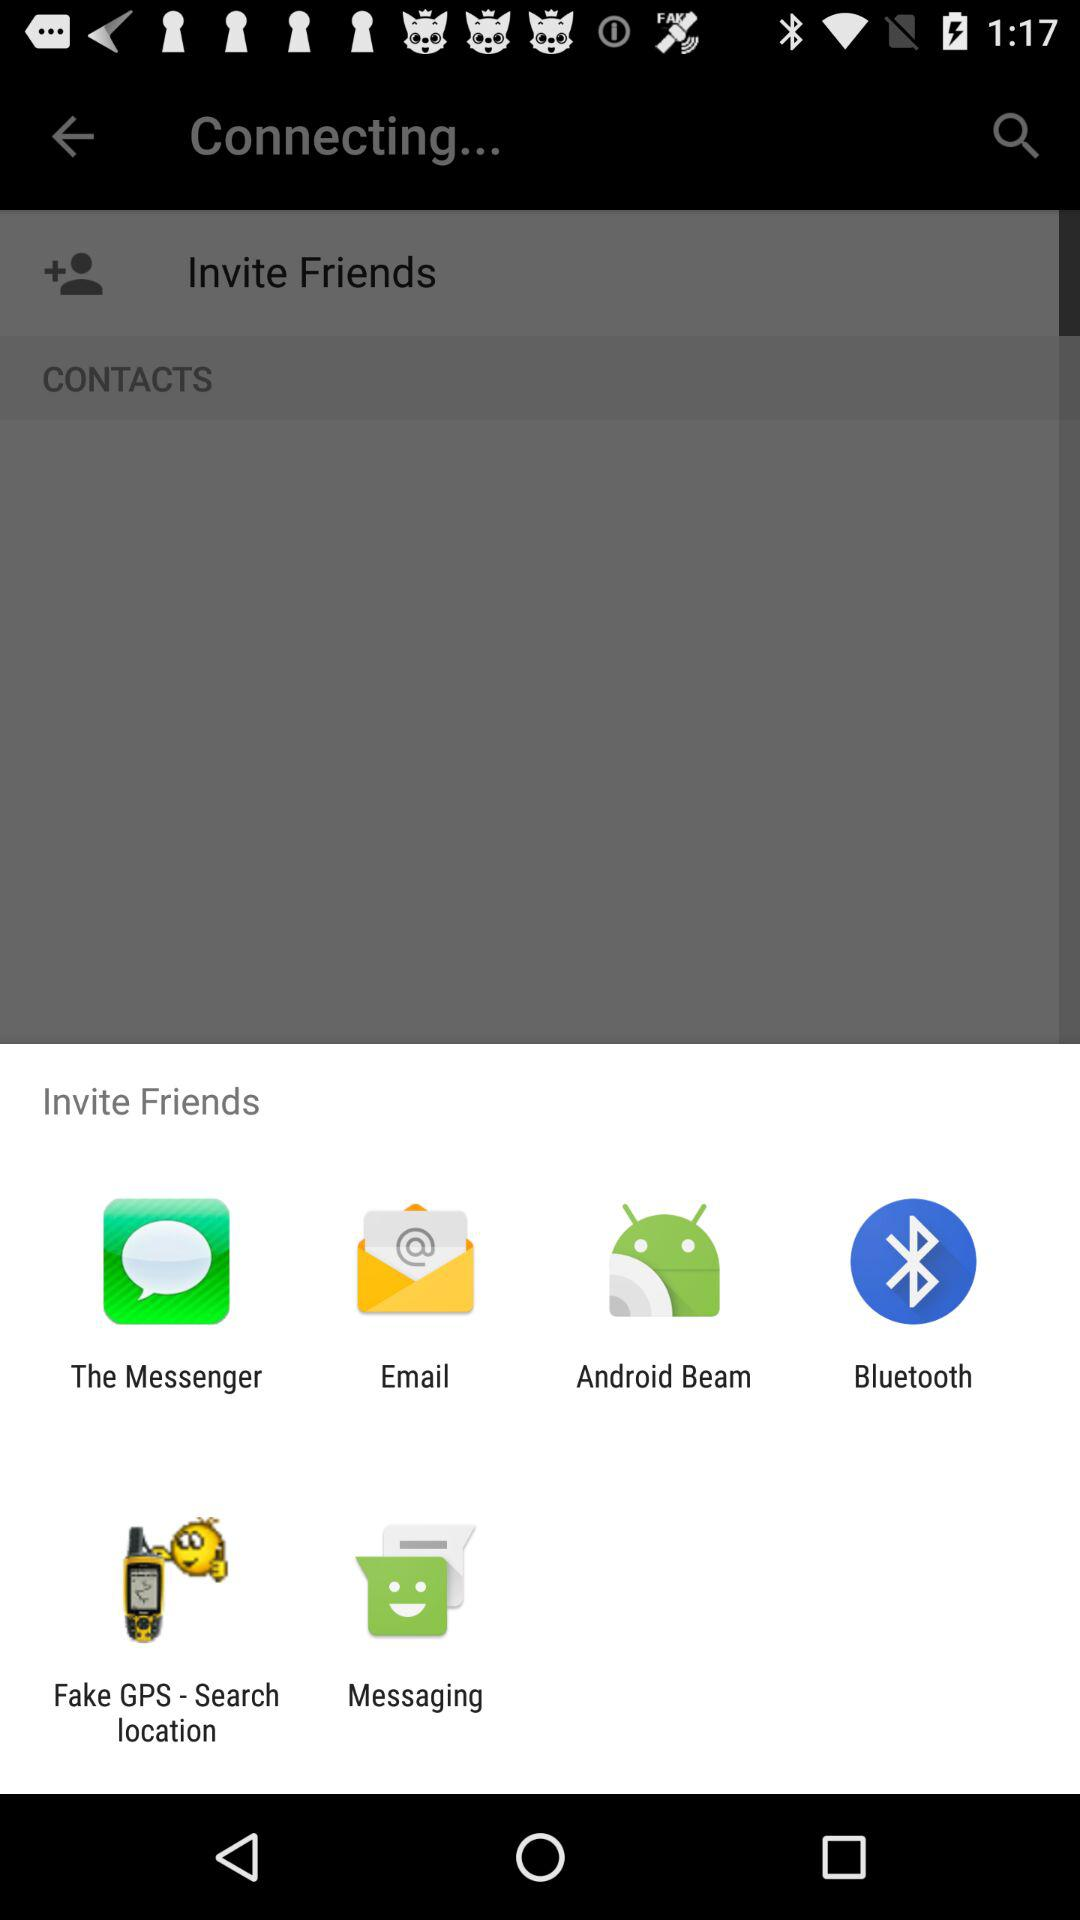What are the options available for inviting friends? The options are "The Messenger", "Email", "Android Beam", "Bluetooth", "Fake GPS - Search location" and "Messaging". 